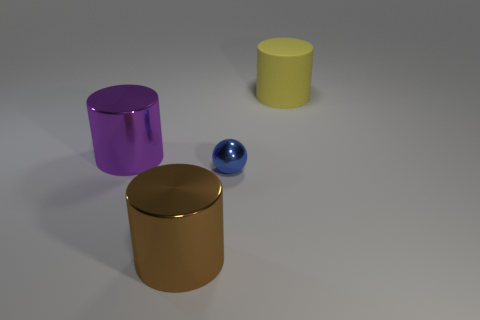What could be the possible uses for these objects in real life? The cylinders could be containers or decorative pieces, while the small blue sphere might be a marble or a decorative ball used for a variety of aesthetic or practical purposes. 